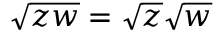Convert formula to latex. <formula><loc_0><loc_0><loc_500><loc_500>{ \sqrt { z w } } = { \sqrt { z } } { \sqrt { w } }</formula> 